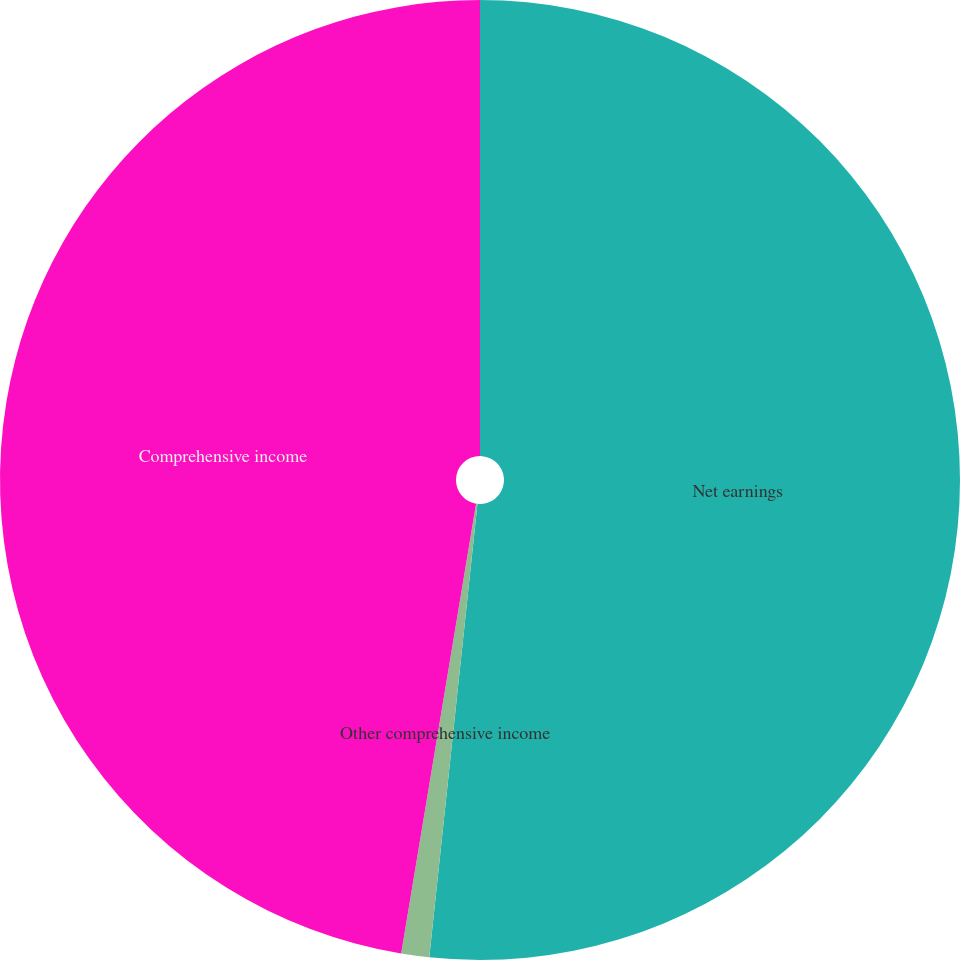<chart> <loc_0><loc_0><loc_500><loc_500><pie_chart><fcel>Net earnings<fcel>Other comprehensive income<fcel>Comprehensive income<nl><fcel>51.68%<fcel>0.94%<fcel>47.37%<nl></chart> 